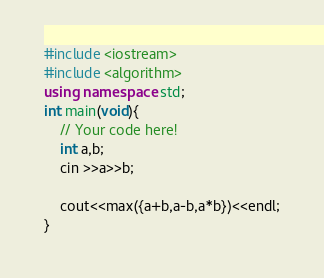<code> <loc_0><loc_0><loc_500><loc_500><_C++_>#include <iostream>
#include <algorithm>
using namespace std;
int main(void){
    // Your code here!
    int a,b;
    cin >>a>>b;
    
    cout<<max({a+b,a-b,a*b})<<endl;
}
</code> 